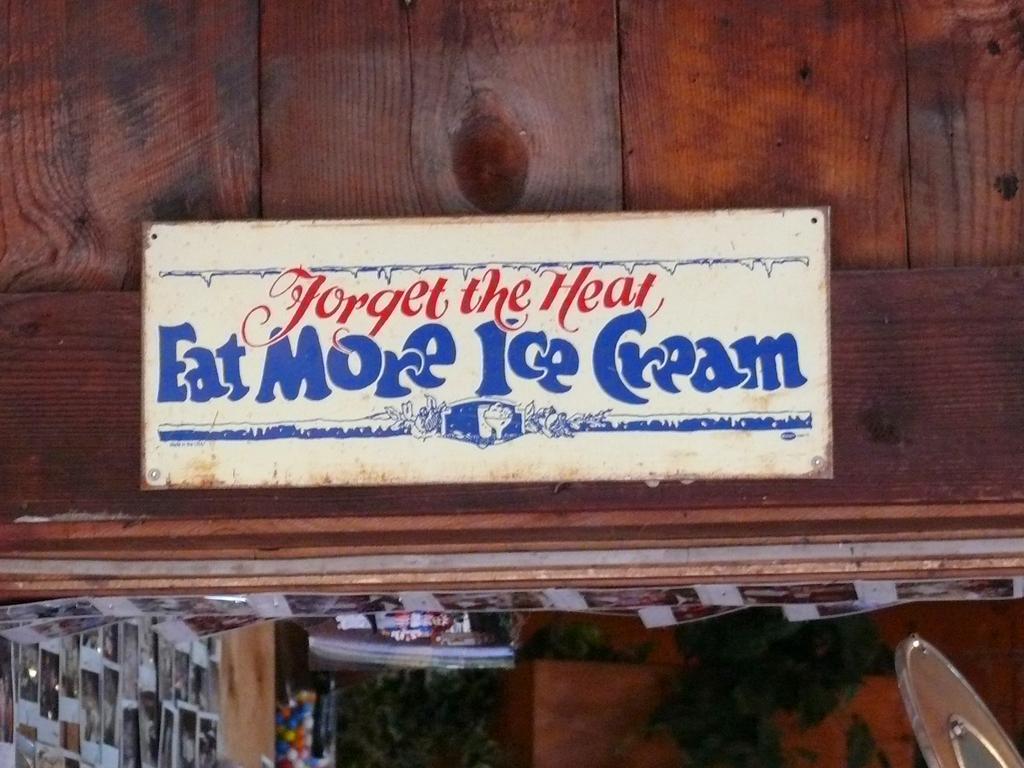In one or two sentences, can you explain what this image depicts? In this image I can see many photos and there is a board attached to the brown color wall. I can see something is written on the board. 